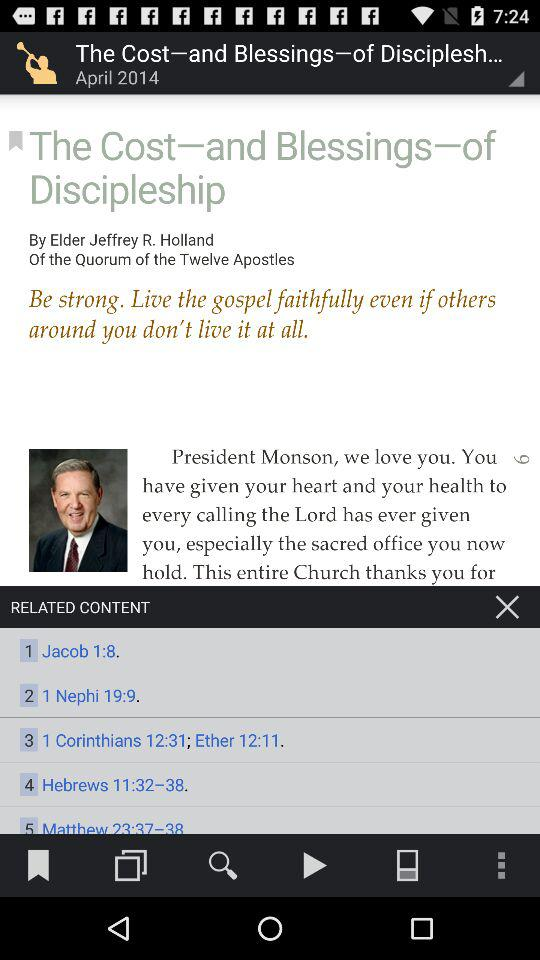What's the publication month and year? The publication month is April and the publication year is 2014. 